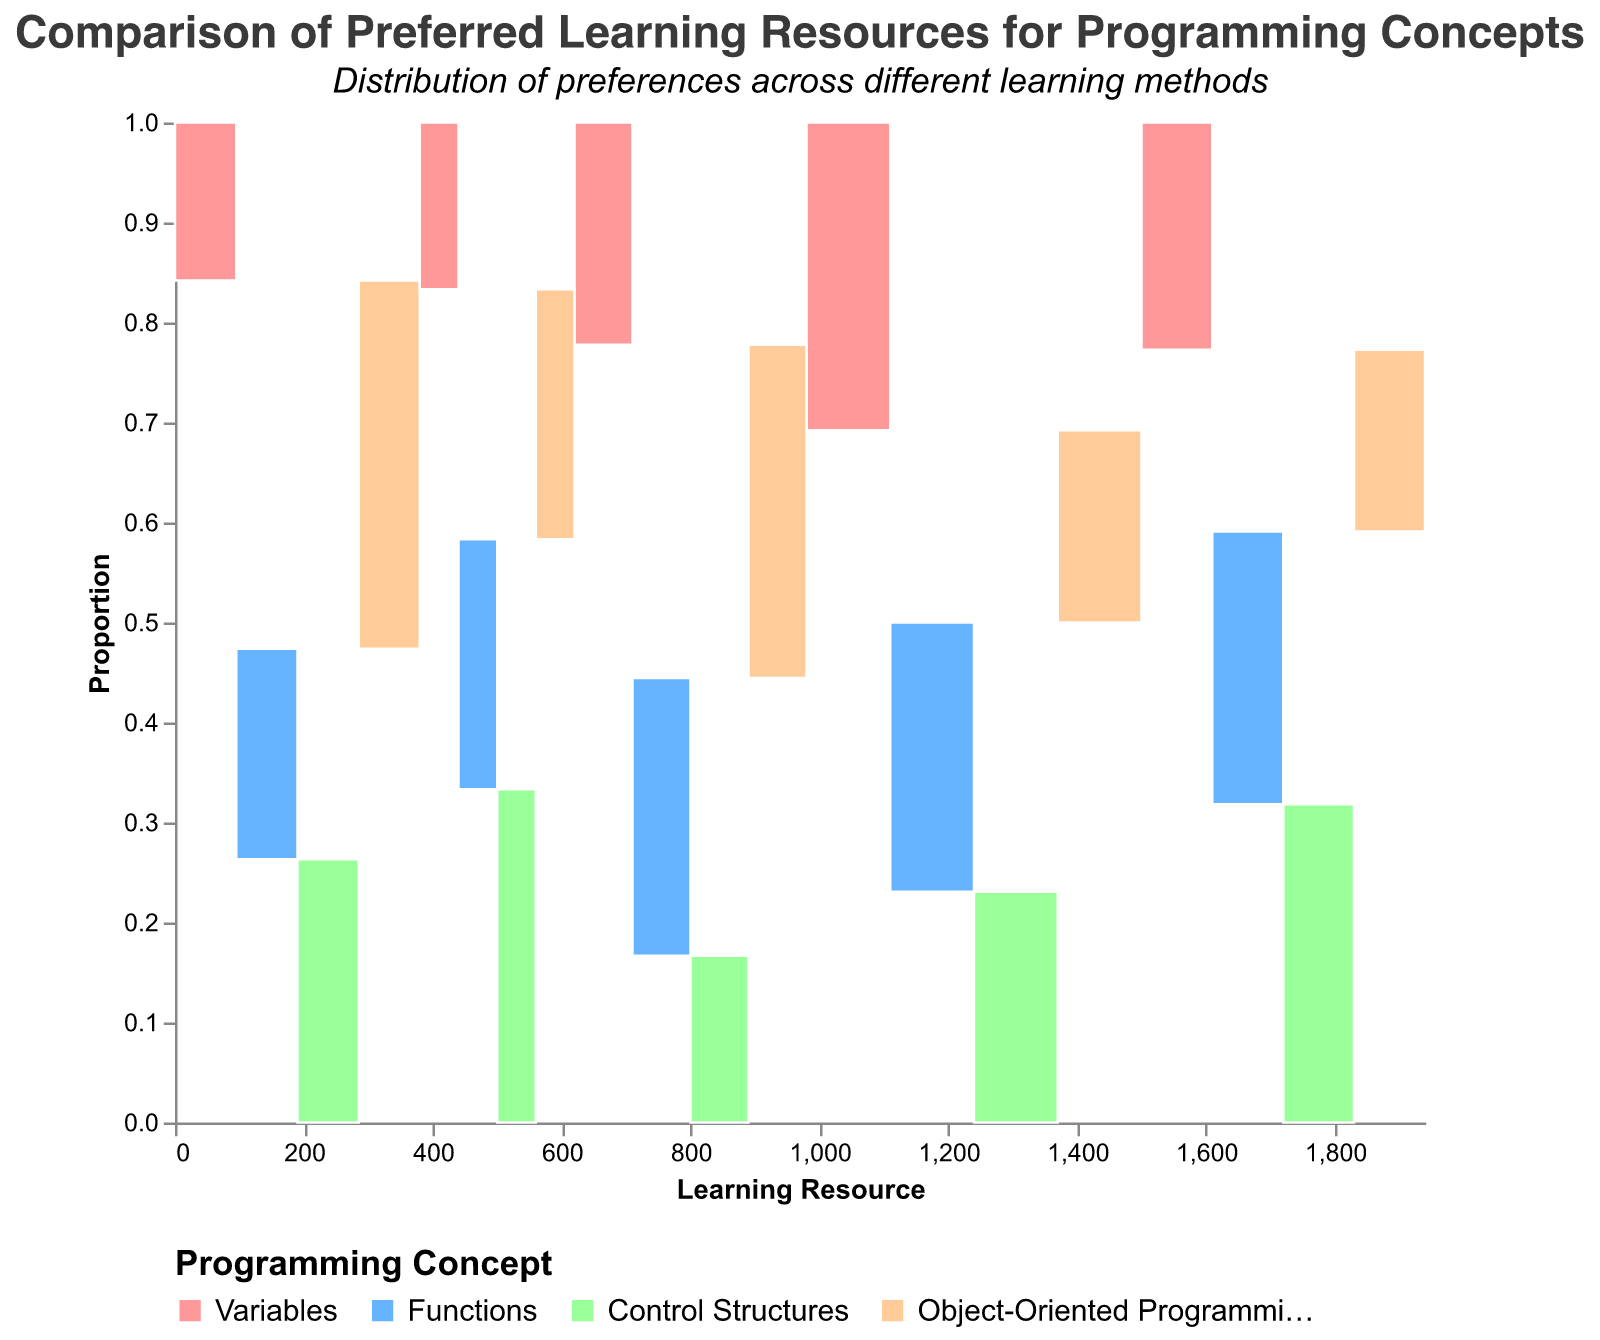What is the title of the figure? The title is usually displayed at the top of the figure. In this case, it reads "Comparison of Preferred Learning Resources for Programming Concepts" with a subtitle.
Answer: Comparison of Preferred Learning Resources for Programming Concepts Which learning resource has the highest preference count for Variables? By looking at the blocks under each Learning Resource category, you can see that the largest block for Variables is under "Online Tutorials".
Answer: Online Tutorials What are the colors representing different programming concepts? The colors in the legend indicate which programming concept corresponds to each color. The colors used are light red, light blue, light green, and light orange.
Answer: Variables (light red), Functions (light blue), Control Structures (light green), Object-Oriented Programming (light orange) How many total preferences are there for Documentation? First, sum the preference counts for all programming concepts under Documentation: 20 (Variables) + 25 (Functions) + 15 (Control Structures) + 30 (Object-Oriented Programming). Then add them up.
Answer: 90 Which programming concept has the most preference for Books? Look at the Books category and identify the largest block. The largest block is for "Object-Oriented Programming".
Answer: Object-Oriented Programming Compare the preference count for Control Structures between Online Tutorials and Books. Which one is higher? Check the height of the Control Structures blocks under Online Tutorials and Books. Online Tutorials has a count of 30, whereas Books has a count of 25. Thus, Online Tutorials is higher.
Answer: Online Tutorials Which learning resource shows the highest preference for Functions? Observe the height or size of the blocks representing Functions under each Learning Resource. The Video Courses category has the tallest/most prominent block for Functions, indicating the highest preference.
Answer: Video Courses Calculate the total proportion of preferences for Control Structures across all learning resources. Sum the preference counts for Control Structures across all learning resources: 30 (Online Tutorials) + 15 (Documentation) + 25 (Books) + 35 (Video Courses) + 20 (Coding Challenges) = 125. Then, find the total preferences across all programming concepts and learning resources: 40 + 35 + 30 + 25 + 20 + 25 + 15 + 30 + 15 + 20 + 25 + 35 + 25 + 30 + 35 + 20 + 10 + 15 + 20 + 15 = 495. Finally, calculate the proportion: 125 / 495 ≈ 0.2525.
Answer: 0.2525 Which learning resource has the least preference count for Object-Oriented Programming? Identify the smallest block for Object-Oriented Programming under each learning resource. "Coding Challenges" has the smallest block with a count of 15.
Answer: Coding Challenges 